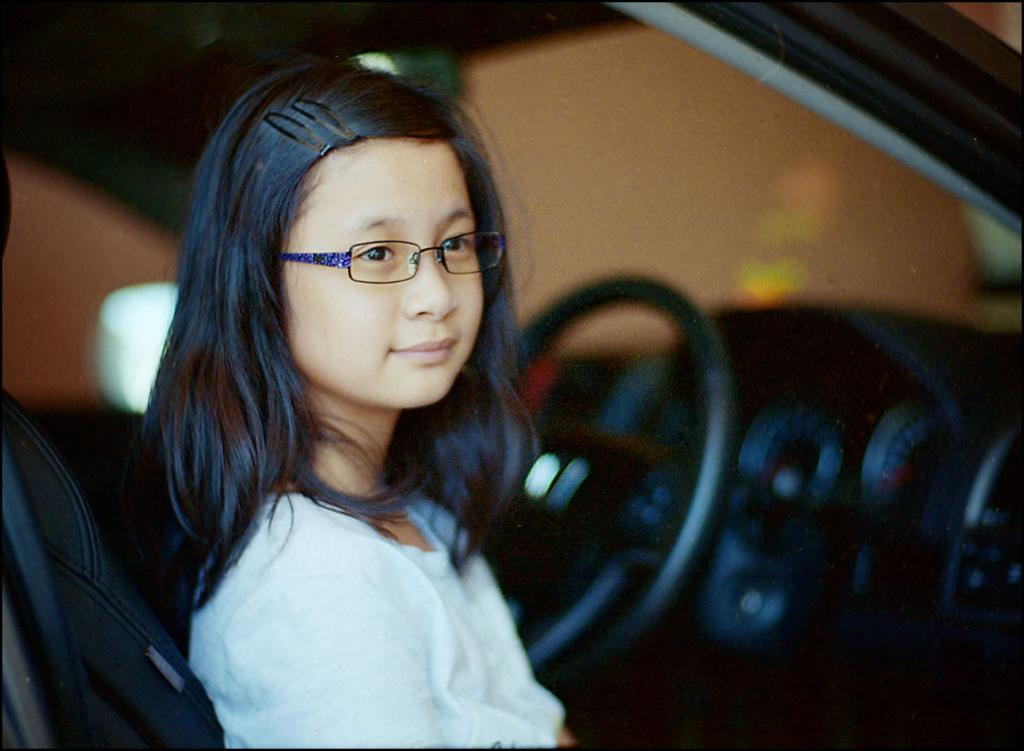Who is the main subject in the image? The main subject in the image is a girl. What is the girl wearing on her face? The girl is wearing spectacles. What is the girl's facial expression? The girl is smiling. What is the girl wearing as her outfit? The girl is wearing a white dress. Where is the girl sitting in the image? The girl is sitting on a car seat. What type of pot is the girl holding in her hand while eating breakfast in the image? There is no pot or breakfast depicted in the image; the girl is sitting on a car seat and wearing spectacles, a smile, and a white dress. 